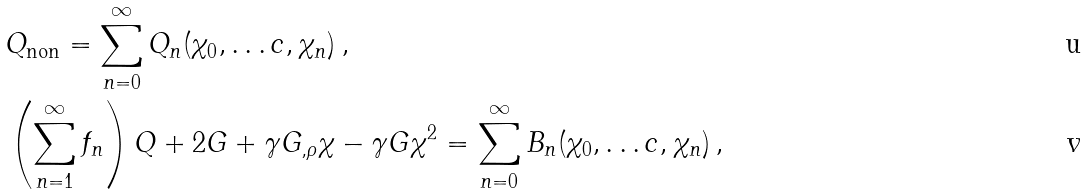<formula> <loc_0><loc_0><loc_500><loc_500>& Q _ { \text {non} } = \sum _ { n = 0 } ^ { \infty } Q _ { n } ( \chi _ { 0 } , \dots c , \chi _ { n } ) \, , \\ & \left ( \sum _ { n = 1 } ^ { \infty } f _ { n } \right ) Q + 2 G + \gamma G _ { , \rho } \chi - \gamma G \chi ^ { 2 } = \sum _ { n = 0 } ^ { \infty } B _ { n } ( \chi _ { 0 } , \dots c , \chi _ { n } ) \, ,</formula> 